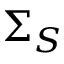<formula> <loc_0><loc_0><loc_500><loc_500>\Sigma _ { S }</formula> 